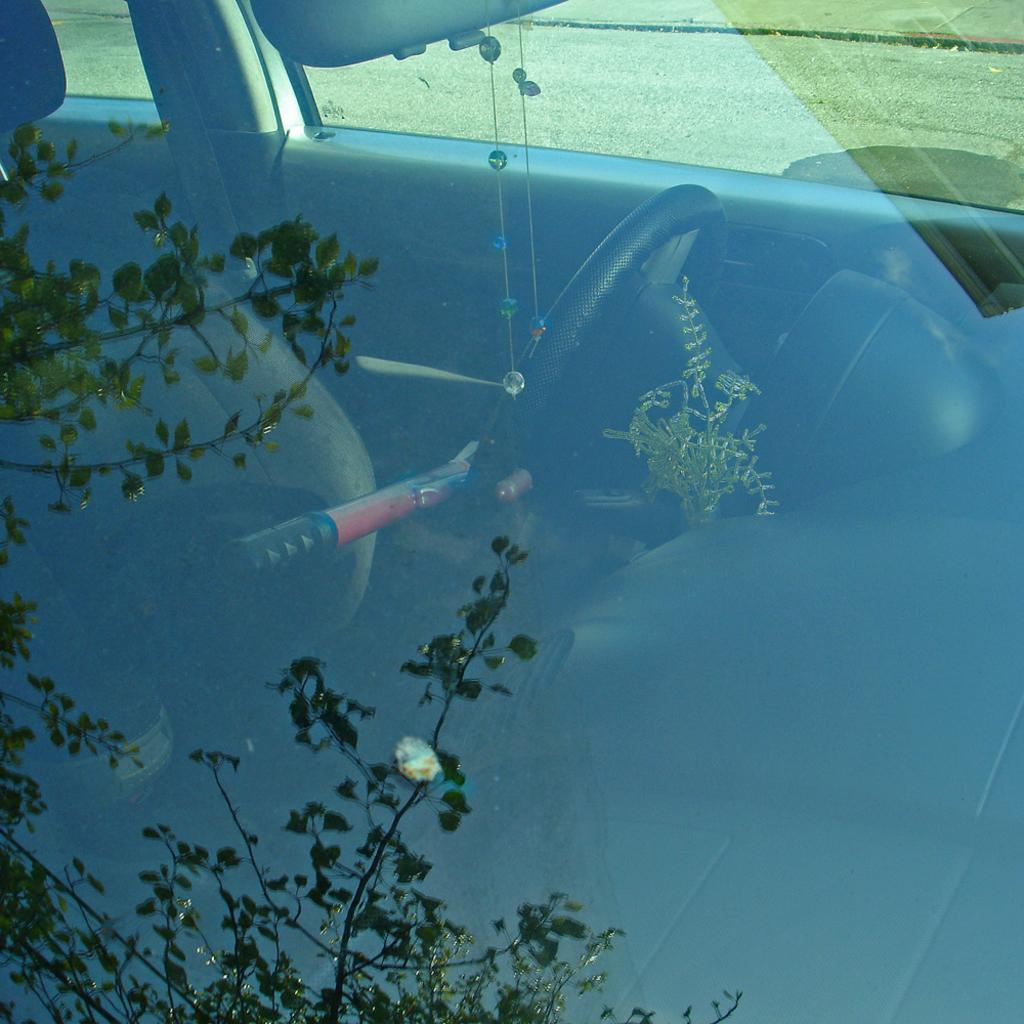What is the main subject of the image? The main subject of the image is a car. What feature can be seen on the car? The car has a windshield. What type of vegetation is visible in the background of the image? There is green grass visible in the background of the image. What type of beetle can be seen crawling on the car's windshield in the image? There is no beetle present on the car's windshield in the image. Who is the servant attending to in the image? There is no servant present in the image. 